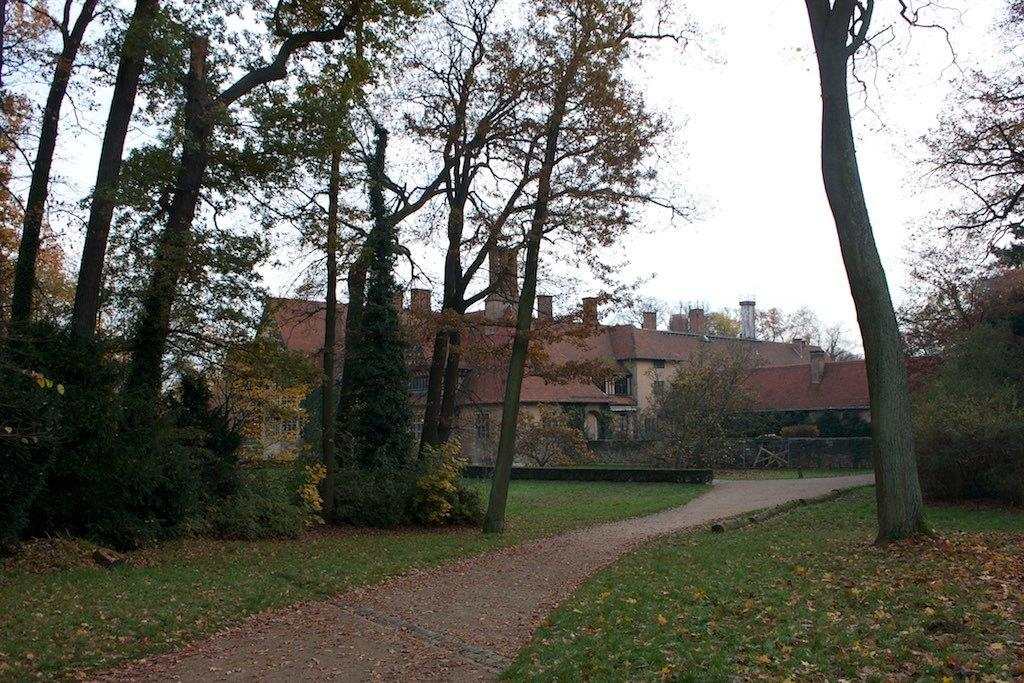What type of structures can be seen in the image? There are buildings in the image. What type of vegetation is present in the image? There are trees in the image. What covers the ground in the image? There is grass on the ground in the image. How would you describe the sky in the image? The sky is cloudy in the image. Can you see a face in the branches of the trees in the image? There is no face visible in the branches of the trees in the image. 